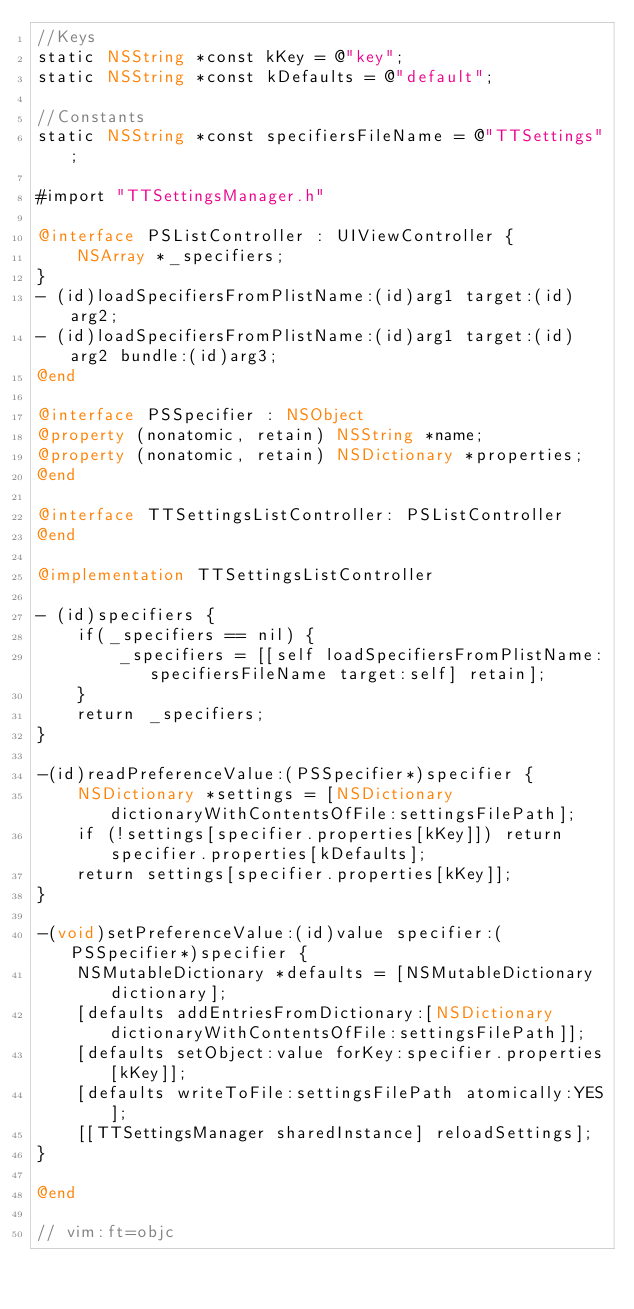<code> <loc_0><loc_0><loc_500><loc_500><_ObjectiveC_>//Keys
static NSString *const kKey = @"key";
static NSString *const kDefaults = @"default";

//Constants
static NSString *const specifiersFileName = @"TTSettings";

#import "TTSettingsManager.h"

@interface PSListController : UIViewController {
    NSArray *_specifiers;
}
- (id)loadSpecifiersFromPlistName:(id)arg1 target:(id)arg2;
- (id)loadSpecifiersFromPlistName:(id)arg1 target:(id)arg2 bundle:(id)arg3;
@end

@interface PSSpecifier : NSObject
@property (nonatomic, retain) NSString *name;
@property (nonatomic, retain) NSDictionary *properties;
@end

@interface TTSettingsListController: PSListController 
@end

@implementation TTSettingsListController

- (id)specifiers {
    if(_specifiers == nil) {
        _specifiers = [[self loadSpecifiersFromPlistName:specifiersFileName target:self] retain];
    }
    return _specifiers;
}

-(id)readPreferenceValue:(PSSpecifier*)specifier {
    NSDictionary *settings = [NSDictionary dictionaryWithContentsOfFile:settingsFilePath];
    if (!settings[specifier.properties[kKey]]) return specifier.properties[kDefaults];
    return settings[specifier.properties[kKey]];
}

-(void)setPreferenceValue:(id)value specifier:(PSSpecifier*)specifier {
    NSMutableDictionary *defaults = [NSMutableDictionary dictionary];
    [defaults addEntriesFromDictionary:[NSDictionary dictionaryWithContentsOfFile:settingsFilePath]];
    [defaults setObject:value forKey:specifier.properties[kKey]];
    [defaults writeToFile:settingsFilePath atomically:YES];
    [[TTSettingsManager sharedInstance] reloadSettings];
}

@end

// vim:ft=objc
</code> 